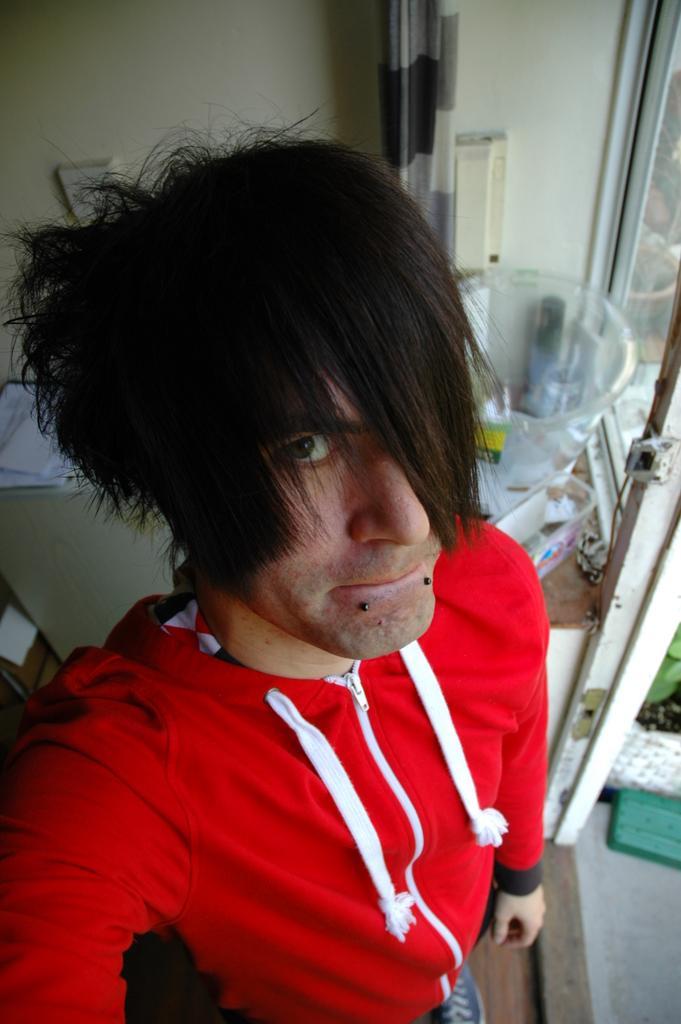How would you summarize this image in a sentence or two? Here I can see a man wearing a red color jacket, standing and taking a selfie. At the back of this person I can see a wall and few objects are placed on a table. 